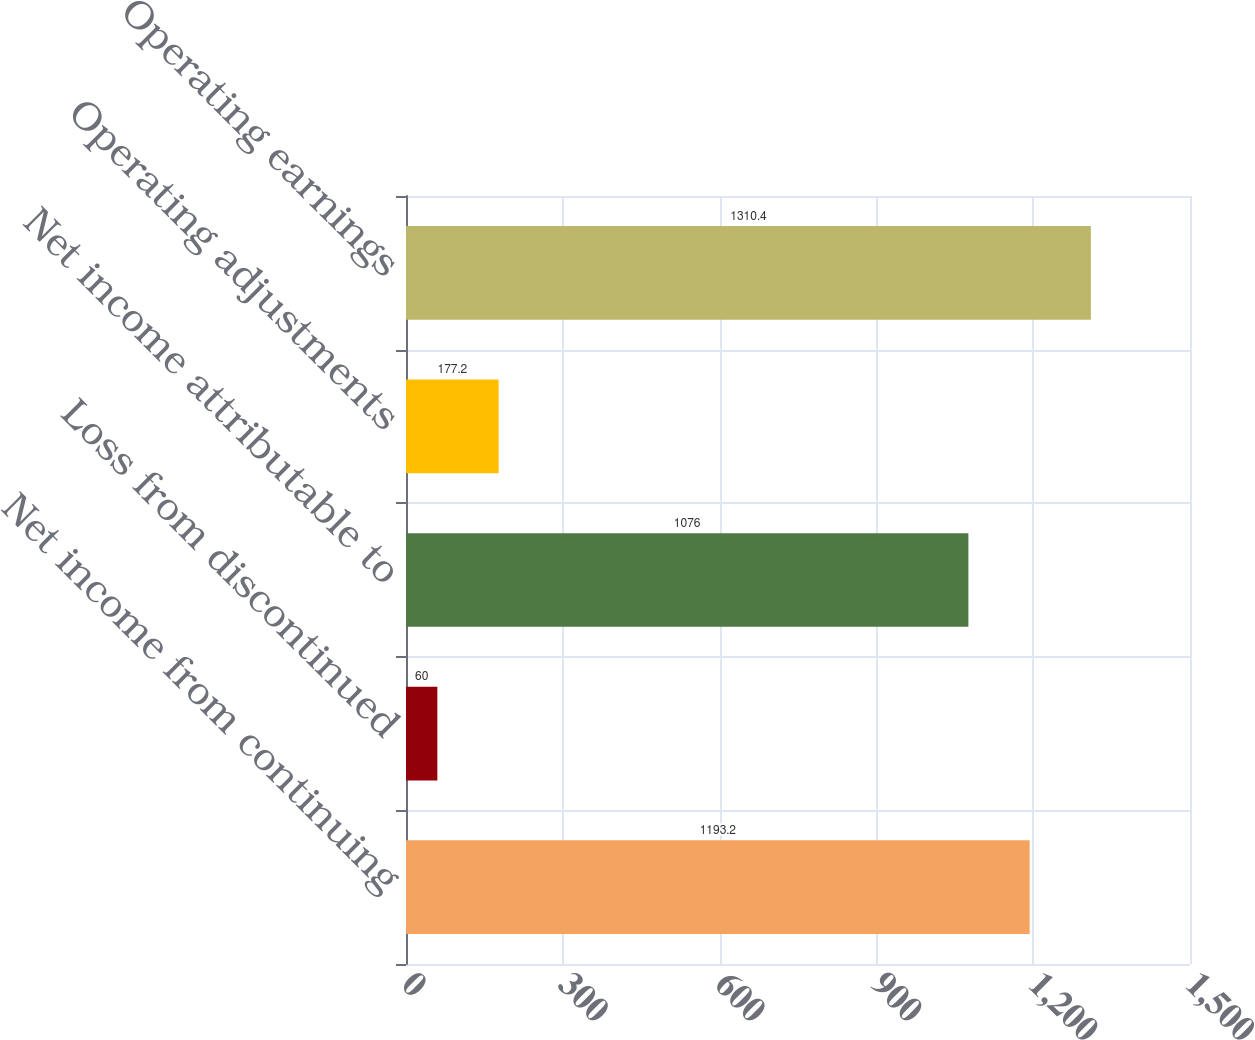<chart> <loc_0><loc_0><loc_500><loc_500><bar_chart><fcel>Net income from continuing<fcel>Loss from discontinued<fcel>Net income attributable to<fcel>Operating adjustments<fcel>Operating earnings<nl><fcel>1193.2<fcel>60<fcel>1076<fcel>177.2<fcel>1310.4<nl></chart> 